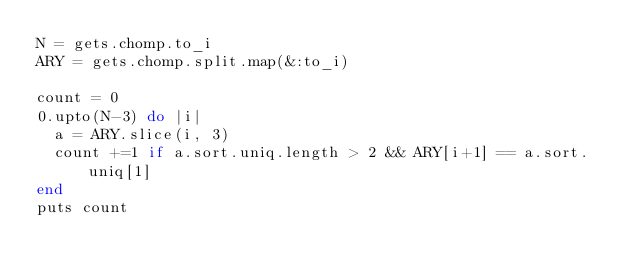<code> <loc_0><loc_0><loc_500><loc_500><_Ruby_>N = gets.chomp.to_i
ARY = gets.chomp.split.map(&:to_i)

count = 0
0.upto(N-3) do |i|
  a = ARY.slice(i, 3)
  count +=1 if a.sort.uniq.length > 2 && ARY[i+1] == a.sort.uniq[1]
end
puts count
</code> 